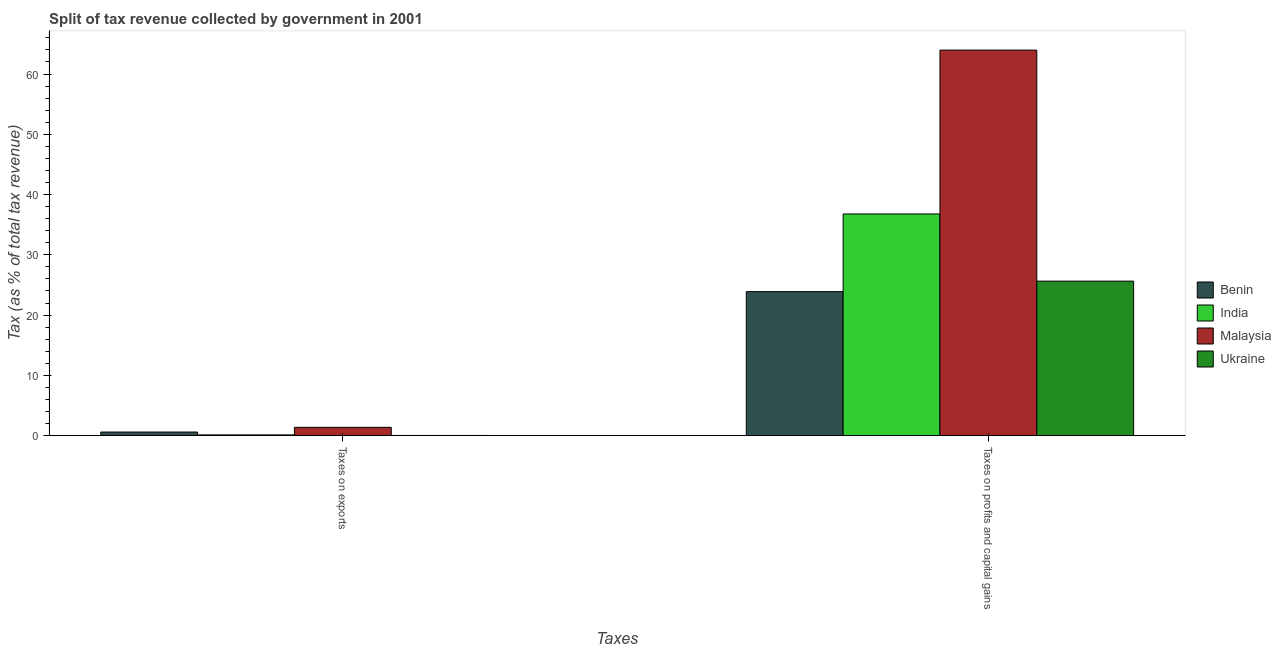What is the label of the 1st group of bars from the left?
Offer a terse response. Taxes on exports. What is the percentage of revenue obtained from taxes on exports in India?
Your answer should be very brief. 0.13. Across all countries, what is the maximum percentage of revenue obtained from taxes on profits and capital gains?
Ensure brevity in your answer.  63.97. Across all countries, what is the minimum percentage of revenue obtained from taxes on profits and capital gains?
Make the answer very short. 23.9. In which country was the percentage of revenue obtained from taxes on exports maximum?
Your response must be concise. Malaysia. In which country was the percentage of revenue obtained from taxes on exports minimum?
Provide a short and direct response. Ukraine. What is the total percentage of revenue obtained from taxes on profits and capital gains in the graph?
Provide a succinct answer. 150.28. What is the difference between the percentage of revenue obtained from taxes on profits and capital gains in Ukraine and that in Malaysia?
Make the answer very short. -38.33. What is the difference between the percentage of revenue obtained from taxes on profits and capital gains in Malaysia and the percentage of revenue obtained from taxes on exports in Benin?
Make the answer very short. 63.37. What is the average percentage of revenue obtained from taxes on profits and capital gains per country?
Your answer should be very brief. 37.57. What is the difference between the percentage of revenue obtained from taxes on profits and capital gains and percentage of revenue obtained from taxes on exports in Malaysia?
Provide a short and direct response. 62.59. In how many countries, is the percentage of revenue obtained from taxes on exports greater than 44 %?
Keep it short and to the point. 0. What is the ratio of the percentage of revenue obtained from taxes on profits and capital gains in Malaysia to that in Ukraine?
Ensure brevity in your answer.  2.5. Is the percentage of revenue obtained from taxes on profits and capital gains in Ukraine less than that in Malaysia?
Provide a succinct answer. Yes. What does the 3rd bar from the left in Taxes on profits and capital gains represents?
Provide a short and direct response. Malaysia. Are all the bars in the graph horizontal?
Give a very brief answer. No. Are the values on the major ticks of Y-axis written in scientific E-notation?
Ensure brevity in your answer.  No. Does the graph contain grids?
Keep it short and to the point. No. Where does the legend appear in the graph?
Provide a succinct answer. Center right. How many legend labels are there?
Provide a succinct answer. 4. How are the legend labels stacked?
Provide a short and direct response. Vertical. What is the title of the graph?
Offer a very short reply. Split of tax revenue collected by government in 2001. Does "Dominican Republic" appear as one of the legend labels in the graph?
Your answer should be compact. No. What is the label or title of the X-axis?
Provide a succinct answer. Taxes. What is the label or title of the Y-axis?
Give a very brief answer. Tax (as % of total tax revenue). What is the Tax (as % of total tax revenue) of Benin in Taxes on exports?
Give a very brief answer. 0.6. What is the Tax (as % of total tax revenue) of India in Taxes on exports?
Provide a succinct answer. 0.13. What is the Tax (as % of total tax revenue) of Malaysia in Taxes on exports?
Ensure brevity in your answer.  1.38. What is the Tax (as % of total tax revenue) of Ukraine in Taxes on exports?
Give a very brief answer. 0.03. What is the Tax (as % of total tax revenue) of Benin in Taxes on profits and capital gains?
Provide a short and direct response. 23.9. What is the Tax (as % of total tax revenue) in India in Taxes on profits and capital gains?
Make the answer very short. 36.78. What is the Tax (as % of total tax revenue) in Malaysia in Taxes on profits and capital gains?
Your answer should be very brief. 63.97. What is the Tax (as % of total tax revenue) in Ukraine in Taxes on profits and capital gains?
Provide a succinct answer. 25.64. Across all Taxes, what is the maximum Tax (as % of total tax revenue) of Benin?
Provide a succinct answer. 23.9. Across all Taxes, what is the maximum Tax (as % of total tax revenue) in India?
Provide a succinct answer. 36.78. Across all Taxes, what is the maximum Tax (as % of total tax revenue) of Malaysia?
Ensure brevity in your answer.  63.97. Across all Taxes, what is the maximum Tax (as % of total tax revenue) of Ukraine?
Give a very brief answer. 25.64. Across all Taxes, what is the minimum Tax (as % of total tax revenue) of Benin?
Keep it short and to the point. 0.6. Across all Taxes, what is the minimum Tax (as % of total tax revenue) in India?
Give a very brief answer. 0.13. Across all Taxes, what is the minimum Tax (as % of total tax revenue) in Malaysia?
Make the answer very short. 1.38. Across all Taxes, what is the minimum Tax (as % of total tax revenue) of Ukraine?
Keep it short and to the point. 0.03. What is the total Tax (as % of total tax revenue) of Benin in the graph?
Your answer should be very brief. 24.49. What is the total Tax (as % of total tax revenue) of India in the graph?
Your response must be concise. 36.91. What is the total Tax (as % of total tax revenue) in Malaysia in the graph?
Make the answer very short. 65.35. What is the total Tax (as % of total tax revenue) of Ukraine in the graph?
Provide a succinct answer. 25.67. What is the difference between the Tax (as % of total tax revenue) of Benin in Taxes on exports and that in Taxes on profits and capital gains?
Your answer should be compact. -23.3. What is the difference between the Tax (as % of total tax revenue) in India in Taxes on exports and that in Taxes on profits and capital gains?
Your response must be concise. -36.65. What is the difference between the Tax (as % of total tax revenue) of Malaysia in Taxes on exports and that in Taxes on profits and capital gains?
Ensure brevity in your answer.  -62.59. What is the difference between the Tax (as % of total tax revenue) of Ukraine in Taxes on exports and that in Taxes on profits and capital gains?
Provide a succinct answer. -25.61. What is the difference between the Tax (as % of total tax revenue) of Benin in Taxes on exports and the Tax (as % of total tax revenue) of India in Taxes on profits and capital gains?
Your response must be concise. -36.18. What is the difference between the Tax (as % of total tax revenue) of Benin in Taxes on exports and the Tax (as % of total tax revenue) of Malaysia in Taxes on profits and capital gains?
Your answer should be very brief. -63.37. What is the difference between the Tax (as % of total tax revenue) of Benin in Taxes on exports and the Tax (as % of total tax revenue) of Ukraine in Taxes on profits and capital gains?
Keep it short and to the point. -25.04. What is the difference between the Tax (as % of total tax revenue) in India in Taxes on exports and the Tax (as % of total tax revenue) in Malaysia in Taxes on profits and capital gains?
Offer a terse response. -63.84. What is the difference between the Tax (as % of total tax revenue) of India in Taxes on exports and the Tax (as % of total tax revenue) of Ukraine in Taxes on profits and capital gains?
Provide a succinct answer. -25.51. What is the difference between the Tax (as % of total tax revenue) of Malaysia in Taxes on exports and the Tax (as % of total tax revenue) of Ukraine in Taxes on profits and capital gains?
Offer a very short reply. -24.25. What is the average Tax (as % of total tax revenue) in Benin per Taxes?
Provide a short and direct response. 12.25. What is the average Tax (as % of total tax revenue) in India per Taxes?
Offer a terse response. 18.45. What is the average Tax (as % of total tax revenue) in Malaysia per Taxes?
Provide a succinct answer. 32.67. What is the average Tax (as % of total tax revenue) in Ukraine per Taxes?
Offer a terse response. 12.83. What is the difference between the Tax (as % of total tax revenue) of Benin and Tax (as % of total tax revenue) of India in Taxes on exports?
Make the answer very short. 0.47. What is the difference between the Tax (as % of total tax revenue) in Benin and Tax (as % of total tax revenue) in Malaysia in Taxes on exports?
Provide a short and direct response. -0.79. What is the difference between the Tax (as % of total tax revenue) in Benin and Tax (as % of total tax revenue) in Ukraine in Taxes on exports?
Make the answer very short. 0.57. What is the difference between the Tax (as % of total tax revenue) in India and Tax (as % of total tax revenue) in Malaysia in Taxes on exports?
Ensure brevity in your answer.  -1.26. What is the difference between the Tax (as % of total tax revenue) of India and Tax (as % of total tax revenue) of Ukraine in Taxes on exports?
Your answer should be compact. 0.1. What is the difference between the Tax (as % of total tax revenue) in Malaysia and Tax (as % of total tax revenue) in Ukraine in Taxes on exports?
Give a very brief answer. 1.35. What is the difference between the Tax (as % of total tax revenue) of Benin and Tax (as % of total tax revenue) of India in Taxes on profits and capital gains?
Make the answer very short. -12.88. What is the difference between the Tax (as % of total tax revenue) of Benin and Tax (as % of total tax revenue) of Malaysia in Taxes on profits and capital gains?
Give a very brief answer. -40.07. What is the difference between the Tax (as % of total tax revenue) in Benin and Tax (as % of total tax revenue) in Ukraine in Taxes on profits and capital gains?
Provide a succinct answer. -1.74. What is the difference between the Tax (as % of total tax revenue) of India and Tax (as % of total tax revenue) of Malaysia in Taxes on profits and capital gains?
Provide a succinct answer. -27.19. What is the difference between the Tax (as % of total tax revenue) of India and Tax (as % of total tax revenue) of Ukraine in Taxes on profits and capital gains?
Provide a succinct answer. 11.14. What is the difference between the Tax (as % of total tax revenue) in Malaysia and Tax (as % of total tax revenue) in Ukraine in Taxes on profits and capital gains?
Provide a succinct answer. 38.33. What is the ratio of the Tax (as % of total tax revenue) in Benin in Taxes on exports to that in Taxes on profits and capital gains?
Offer a terse response. 0.03. What is the ratio of the Tax (as % of total tax revenue) in India in Taxes on exports to that in Taxes on profits and capital gains?
Offer a terse response. 0. What is the ratio of the Tax (as % of total tax revenue) of Malaysia in Taxes on exports to that in Taxes on profits and capital gains?
Offer a terse response. 0.02. What is the ratio of the Tax (as % of total tax revenue) of Ukraine in Taxes on exports to that in Taxes on profits and capital gains?
Offer a terse response. 0. What is the difference between the highest and the second highest Tax (as % of total tax revenue) in Benin?
Your response must be concise. 23.3. What is the difference between the highest and the second highest Tax (as % of total tax revenue) in India?
Your answer should be compact. 36.65. What is the difference between the highest and the second highest Tax (as % of total tax revenue) of Malaysia?
Offer a terse response. 62.59. What is the difference between the highest and the second highest Tax (as % of total tax revenue) of Ukraine?
Your response must be concise. 25.61. What is the difference between the highest and the lowest Tax (as % of total tax revenue) of Benin?
Ensure brevity in your answer.  23.3. What is the difference between the highest and the lowest Tax (as % of total tax revenue) of India?
Ensure brevity in your answer.  36.65. What is the difference between the highest and the lowest Tax (as % of total tax revenue) of Malaysia?
Make the answer very short. 62.59. What is the difference between the highest and the lowest Tax (as % of total tax revenue) of Ukraine?
Make the answer very short. 25.61. 